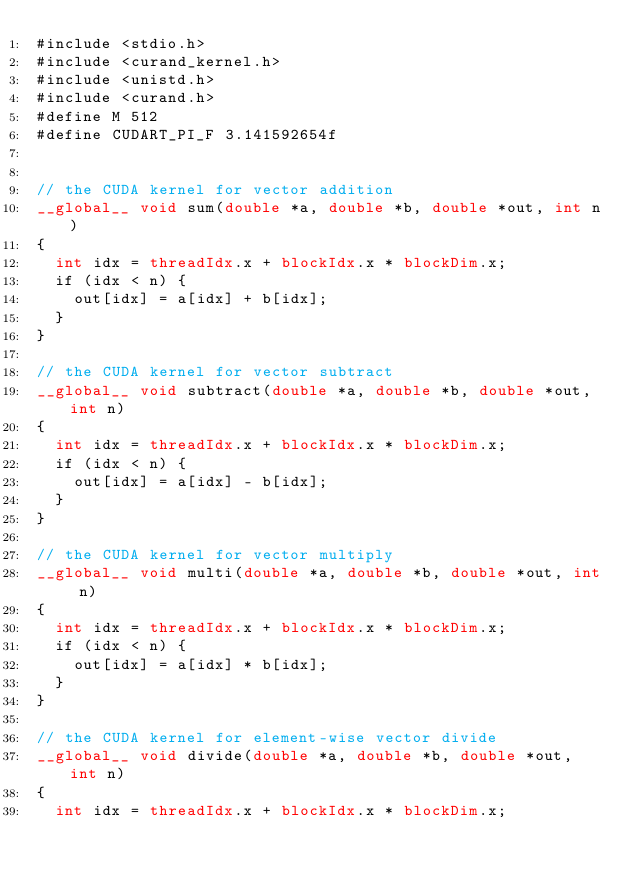<code> <loc_0><loc_0><loc_500><loc_500><_Cuda_>#include <stdio.h>
#include <curand_kernel.h>
#include <unistd.h>
#include <curand.h>
#define M 512
#define CUDART_PI_F 3.141592654f

  
// the CUDA kernel for vector addition
__global__ void sum(double *a, double *b, double *out, int n)
{
	int idx = threadIdx.x + blockIdx.x * blockDim.x;
	if (idx < n) {
		out[idx] = a[idx] + b[idx];
	}
}

// the CUDA kernel for vector subtract
__global__ void subtract(double *a, double *b, double *out, int n)
{
	int idx = threadIdx.x + blockIdx.x * blockDim.x;
	if (idx < n) {
		out[idx] = a[idx] - b[idx];
	}
}

// the CUDA kernel for vector multiply
__global__ void multi(double *a, double *b, double *out, int n)
{
	int idx = threadIdx.x + blockIdx.x * blockDim.x;
	if (idx < n) {
		out[idx] = a[idx] * b[idx];
	}
}

// the CUDA kernel for element-wise vector divide
__global__ void divide(double *a, double *b, double *out, int n)
{
	int idx = threadIdx.x + blockIdx.x * blockDim.x;</code> 